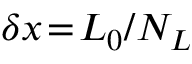<formula> <loc_0><loc_0><loc_500><loc_500>\delta x \, = \, L _ { 0 } / N _ { L }</formula> 